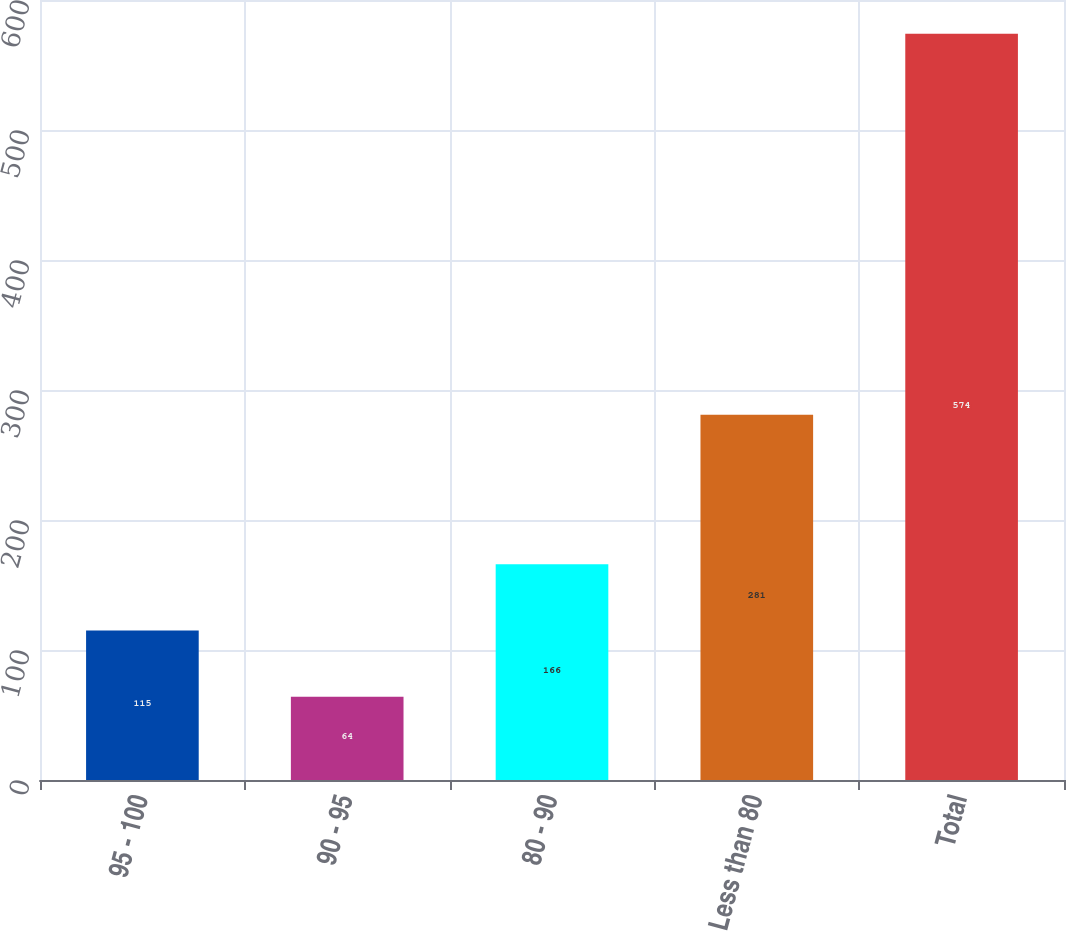Convert chart to OTSL. <chart><loc_0><loc_0><loc_500><loc_500><bar_chart><fcel>95 - 100<fcel>90 - 95<fcel>80 - 90<fcel>Less than 80<fcel>Total<nl><fcel>115<fcel>64<fcel>166<fcel>281<fcel>574<nl></chart> 